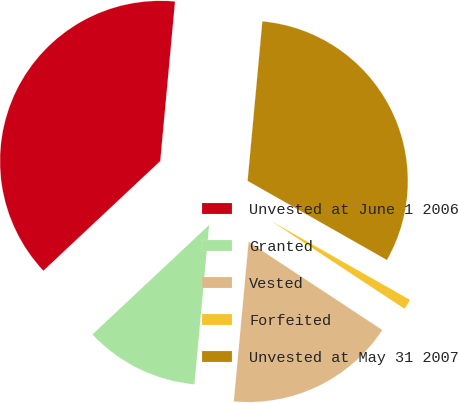Convert chart to OTSL. <chart><loc_0><loc_0><loc_500><loc_500><pie_chart><fcel>Unvested at June 1 2006<fcel>Granted<fcel>Vested<fcel>Forfeited<fcel>Unvested at May 31 2007<nl><fcel>38.46%<fcel>11.54%<fcel>17.2%<fcel>1.05%<fcel>31.75%<nl></chart> 